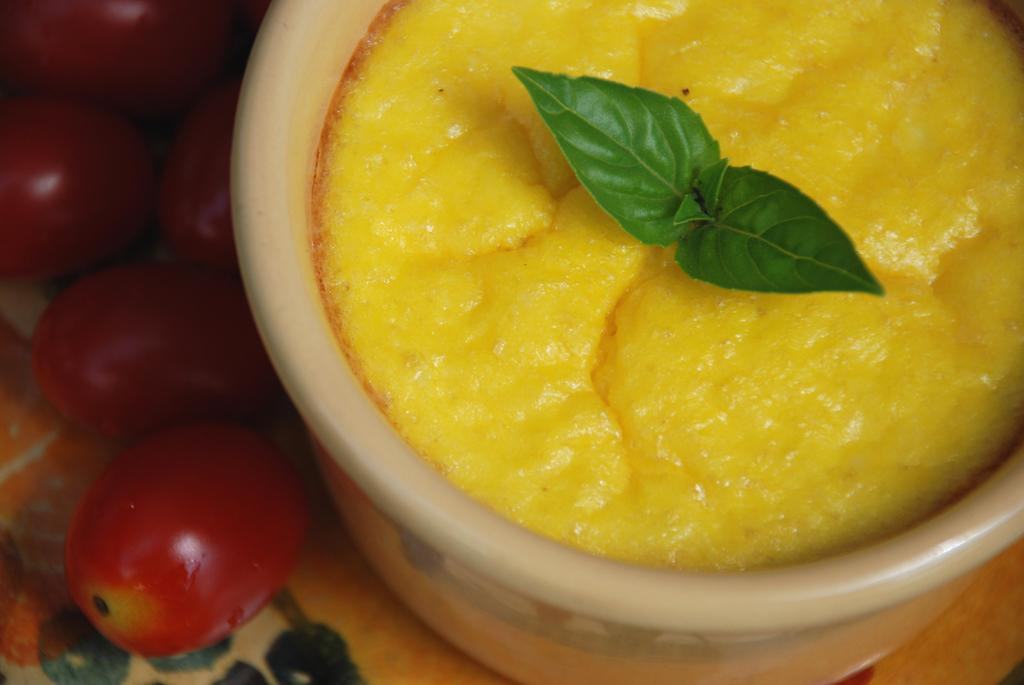What is in the bowl that is visible in the image? There is a bowl with yellow curry in the image. What other food items can be seen in the image? There are red tomatoes in the image. Can you see any snails crawling on the red tomatoes in the image? There are no snails present in the image; it only features a bowl of yellow curry and red tomatoes. 